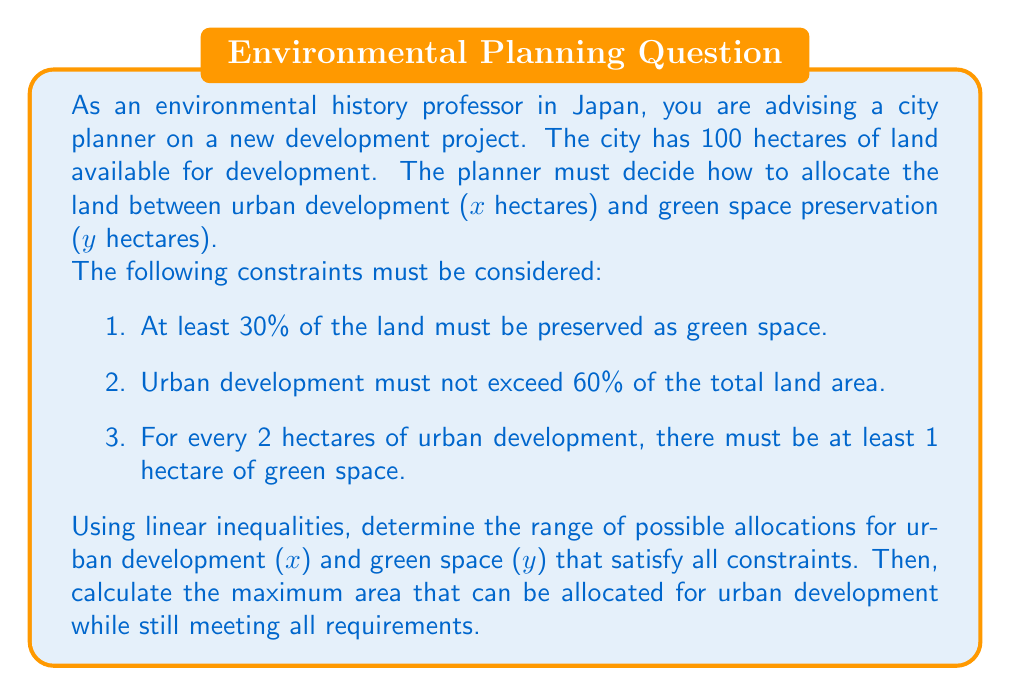Could you help me with this problem? Let's approach this problem step by step:

1. Define variables:
   $x$ = hectares of urban development
   $y$ = hectares of green space preservation

2. Total land constraint:
   $x + y = 100$

3. Express the given constraints as linear inequalities:
   a. At least 30% green space: $y \geq 0.3(100) \Rightarrow y \geq 30$
   b. Urban development not exceeding 60%: $x \leq 0.6(100) \Rightarrow x \leq 60$
   c. For every 2 hectares of urban development, at least 1 hectare of green space: $y \geq \frac{1}{2}x$

4. Combine all constraints:
   $$\begin{cases}
   x + y = 100 \\
   y \geq 30 \\
   x \leq 60 \\
   y \geq \frac{1}{2}x \\
   x \geq 0, y \geq 0
   \end{cases}$$

5. To find the maximum area for urban development, we need to maximize $x$ while satisfying all constraints.

6. The binding constraints are:
   $x + y = 100$
   $y \geq \frac{1}{2}x$

7. Solve these simultaneously:
   $100 - x = \frac{1}{2}x$
   $100 = \frac{3}{2}x$
   $x = \frac{200}{3} \approx 66.67$

8. However, this violates the constraint $x \leq 60$. Therefore, the maximum value for $x$ is 60.

9. When $x = 60$, $y = 100 - 60 = 40$, which satisfies all other constraints.

Thus, the range of possible allocations is:
$30 \leq y \leq 70$
$30 \leq x \leq 60$

And the maximum area for urban development is 60 hectares.
Answer: The range of possible allocations:
$30 \leq y \leq 70$ hectares for green space
$30 \leq x \leq 60$ hectares for urban development

Maximum area for urban development: 60 hectares 